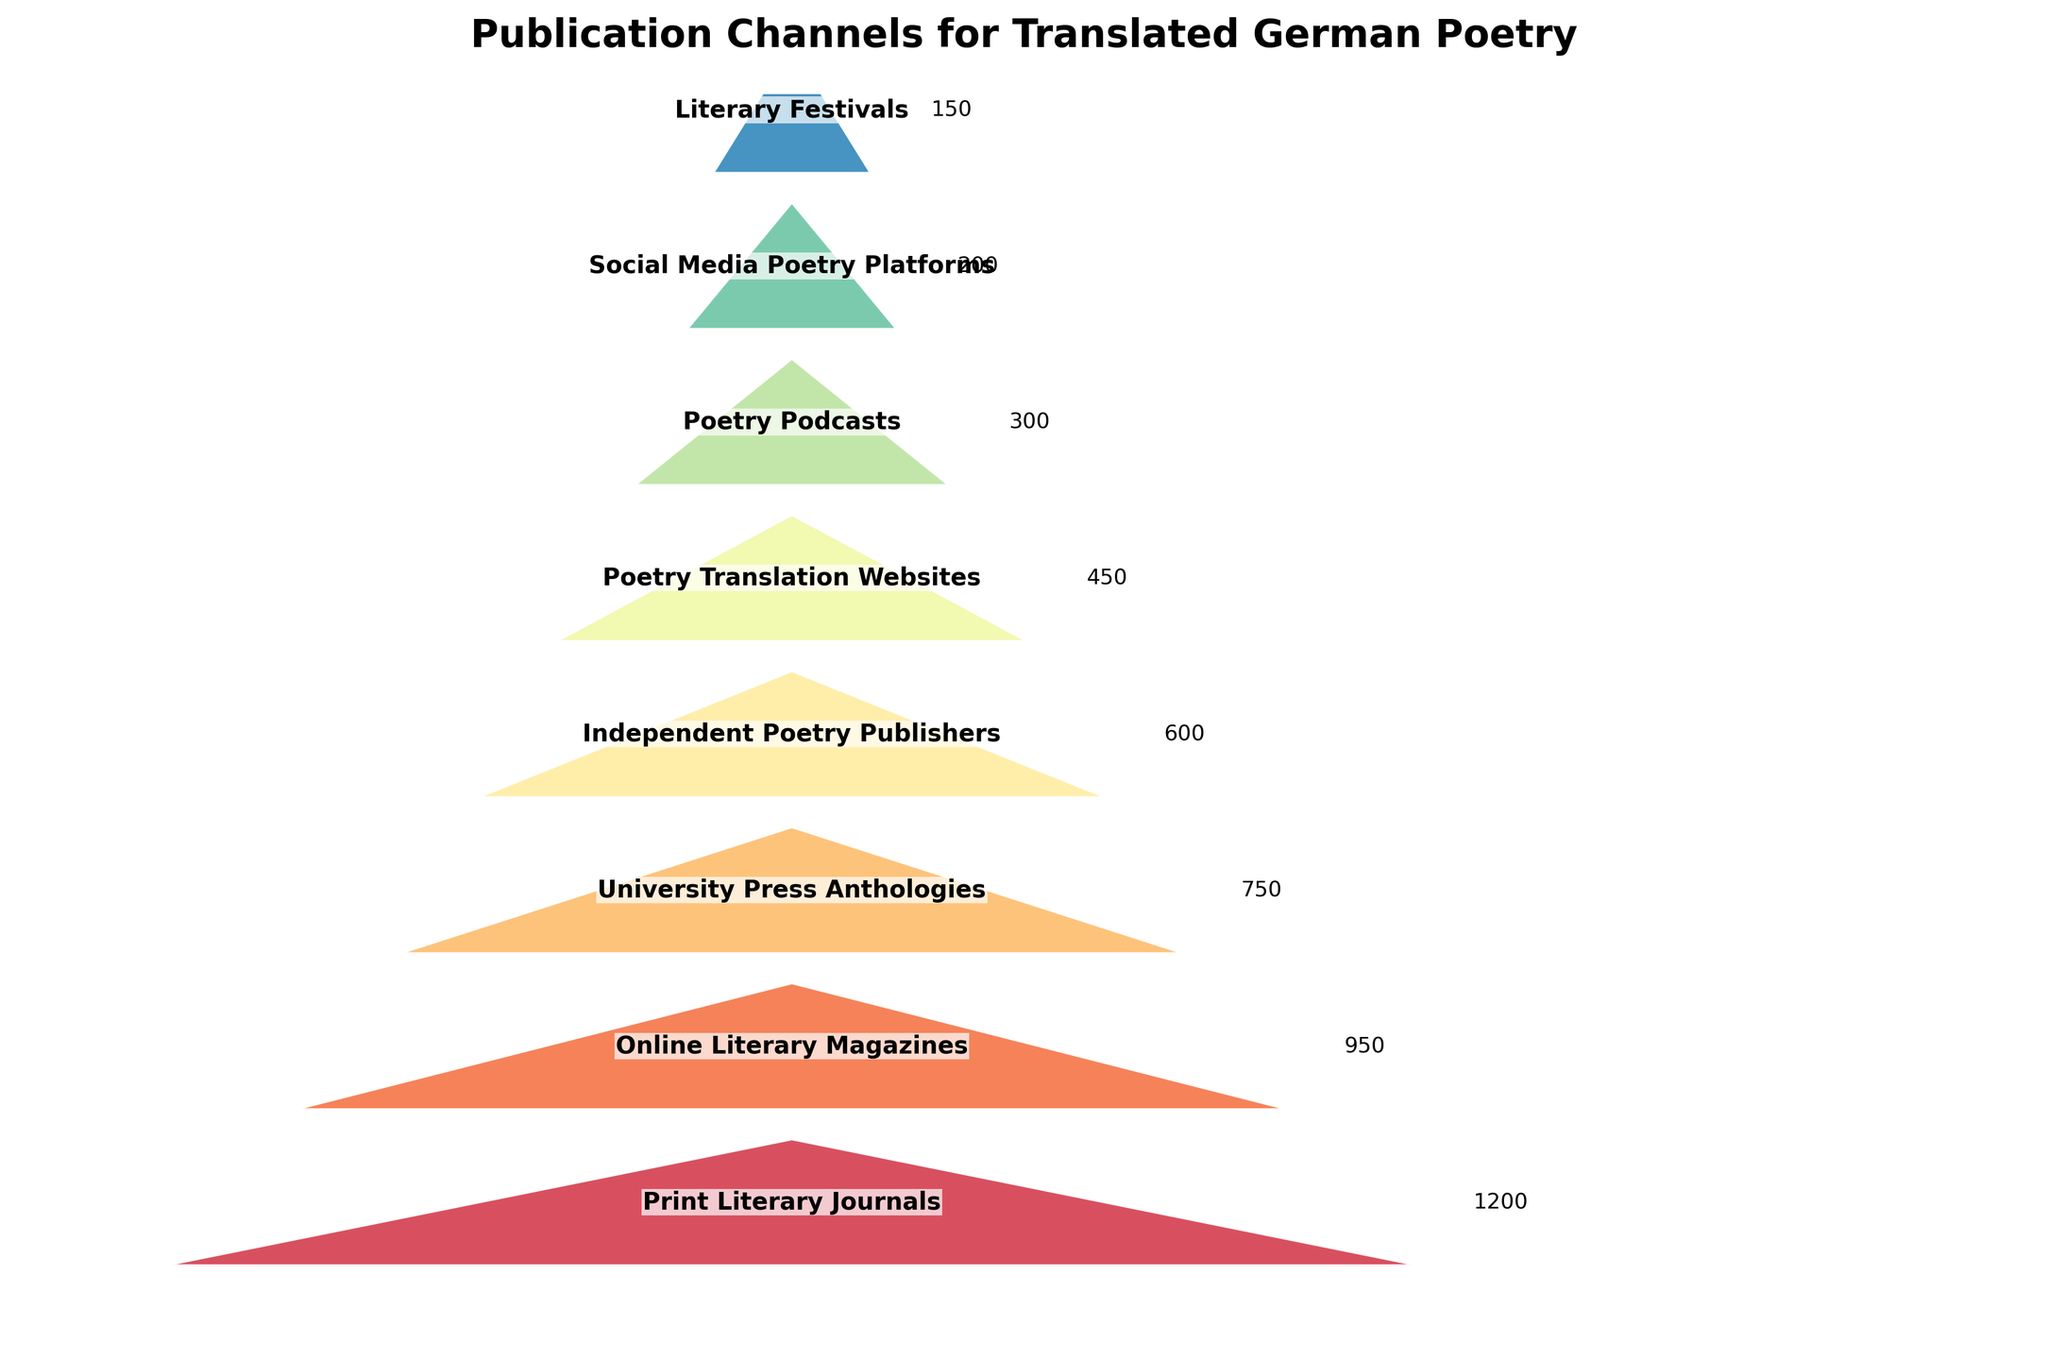What is the title of the figure? The title is located at the top of the figure and is usually in a larger, bold font. The visual element with the largest text is the title.
Answer: Publication Channels for Translated German Poetry Which publication channel has the highest number of translated German poetry publications? The widest section at the top of the funnel represents the stage with the highest number of publications.
Answer: Print Literary Journals How many stages are included in the funnel chart? Count the number of distinct sections from top to bottom in the funnel.
Answer: 8 Which publication channel has the smallest number of translated German poetry publications? The narrowest section at the bottom of the funnel represents the stage with the lowest number of publications.
Answer: Literary Festivals What is the total number of publications across all stages? Sum the number of publications for each stage: 1200 + 950 + 750 + 600 + 450 + 300 + 200 + 150. The sum is 4600.
Answer: 4600 How many more publications are there in Print Literary Journals compared to Online Literary Magazines? Subtract the number of publications in Online Literary Magazines from Print Literary Journals: 1200 - 950. The difference is 250.
Answer: 250 What is the average number of publications per stage? First, sum the total number of publications (4600). Then divide by the number of stages (8): 4600 / 8. The average is 575.
Answer: 575 Between which two consecutive stages is the largest drop in the number of publications? Compare the differences between each pair of consecutive stages: 
1200 - 950 = 250 
950 - 750 = 200 
750 - 600 = 150 
600 - 450 = 150 
450 - 300 = 150 
300 - 200 = 100 
200 - 150 = 50 
The largest drop is between Print Literary Journals and Online Literary Magazines (250).
Answer: Print Literary Journals to Online Literary Magazines Which two stages have the smallest difference in the number of publications? Compare the differences between each pair of consecutive stages:
1200 - 950 = 250 
950 - 750 = 200 
750 - 600 = 150 
600 - 450 = 150 
450 - 300 = 150 
300 - 200 = 100 
200 - 150 = 50 
The smallest difference is between Social Media Poetry Platforms and Literary Festivals (50).
Answer: Social Media Poetry Platforms and Literary Festivals 